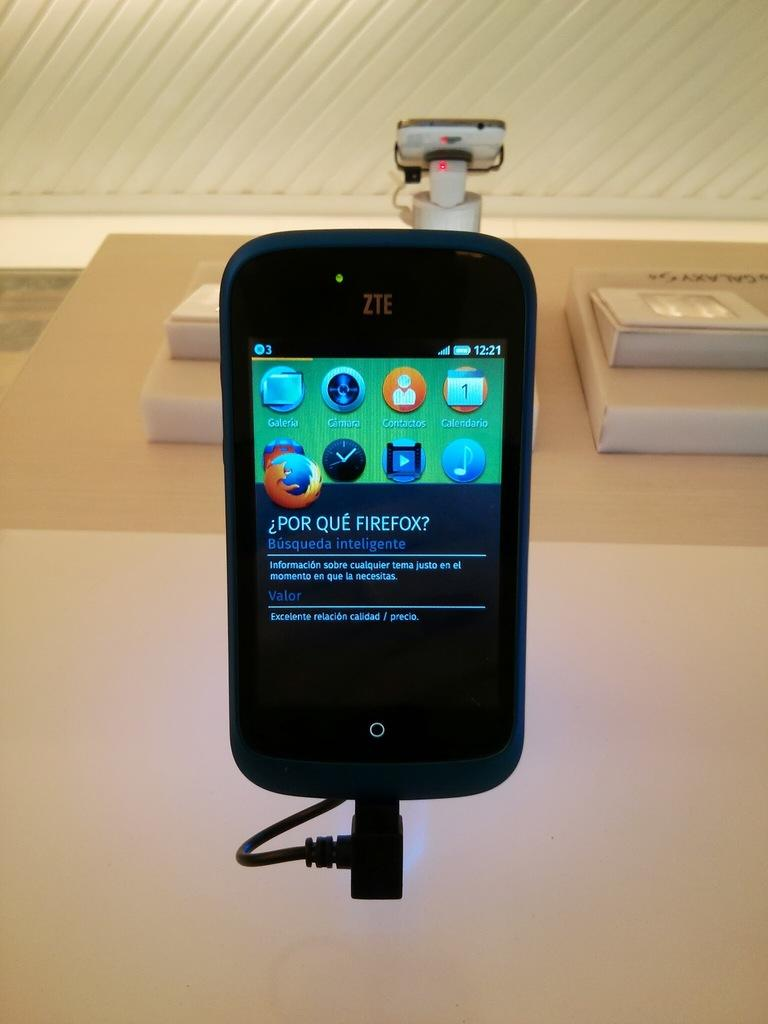<image>
Share a concise interpretation of the image provided. The screen on the ZTE phone displays information about Firefox. 